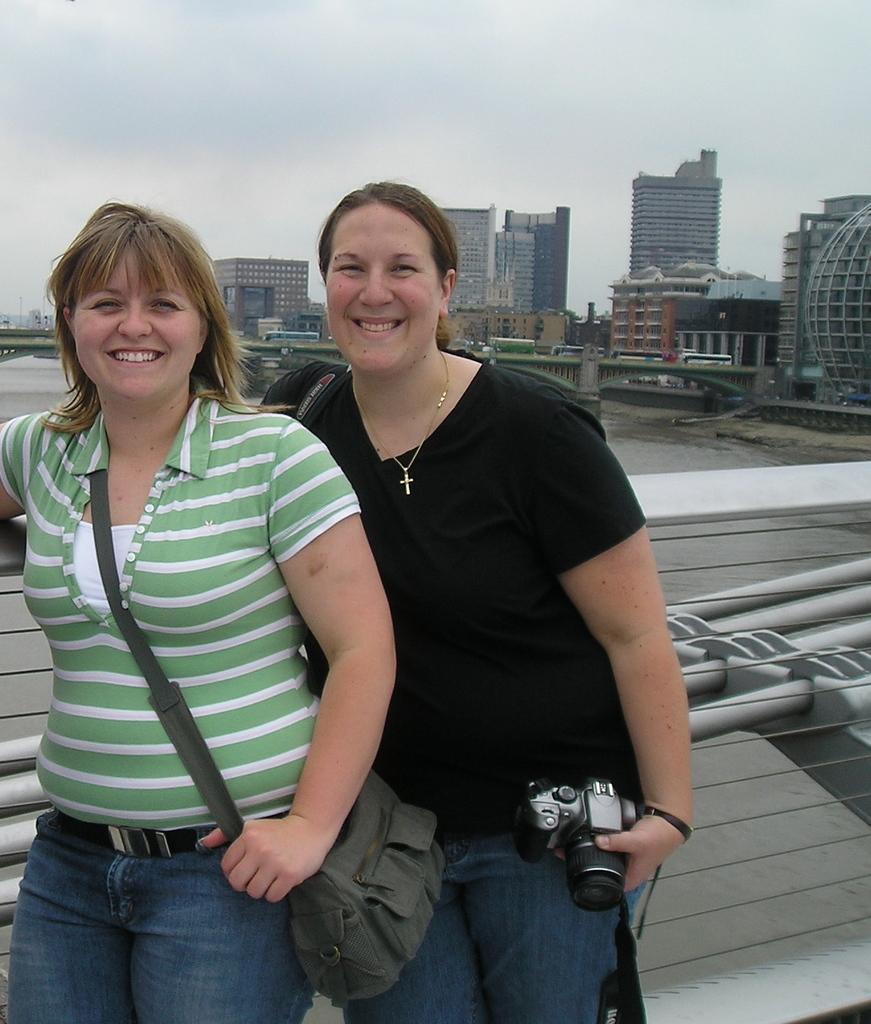In one or two sentences, can you explain what this image depicts? In this image I can see there are two women are standing and smiling. A woman on the left side is carrying a bag and the other woman is holding a camera in her hand. I can also see there are few buildings. 